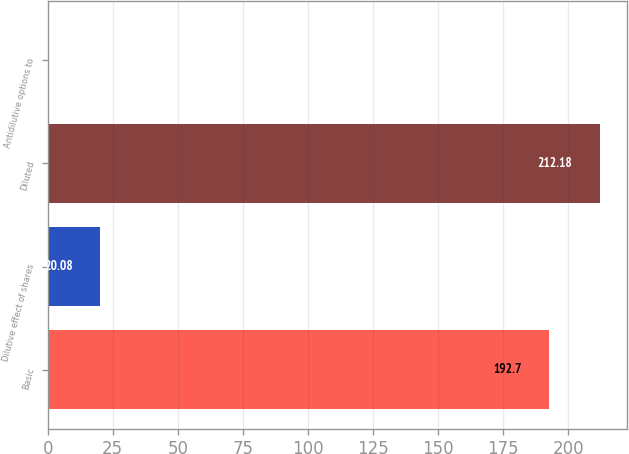Convert chart. <chart><loc_0><loc_0><loc_500><loc_500><bar_chart><fcel>Basic<fcel>Dilutive effect of shares<fcel>Diluted<fcel>Antidilutive options to<nl><fcel>192.7<fcel>20.08<fcel>212.18<fcel>0.6<nl></chart> 